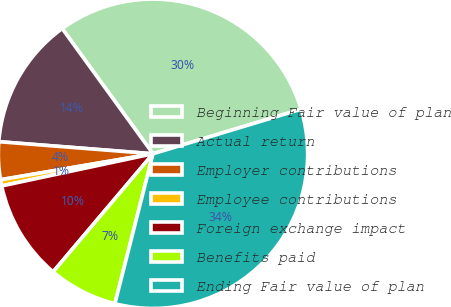Convert chart. <chart><loc_0><loc_0><loc_500><loc_500><pie_chart><fcel>Beginning Fair value of plan<fcel>Actual return<fcel>Employer contributions<fcel>Employee contributions<fcel>Foreign exchange impact<fcel>Benefits paid<fcel>Ending Fair value of plan<nl><fcel>30.33%<fcel>13.77%<fcel>3.93%<fcel>0.65%<fcel>10.49%<fcel>7.21%<fcel>33.61%<nl></chart> 